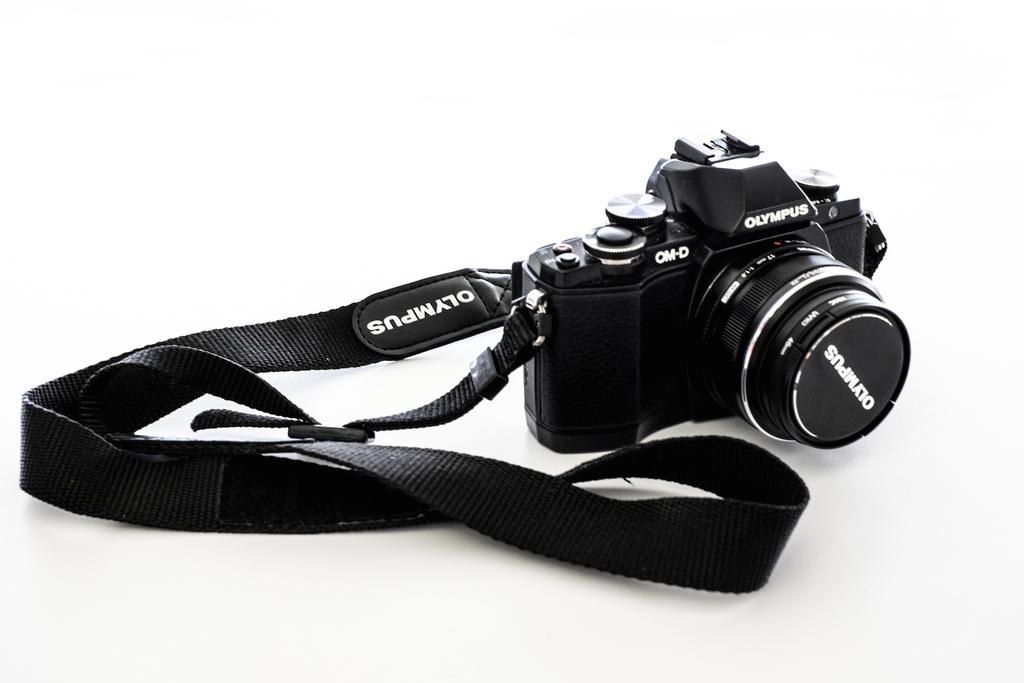What object is the main subject of the picture? The main subject of the picture is a camera. What is the color of the camera? The camera is black in color. Are there any markings or text on the camera? Yes, there are words written on the camera. Is there anything attached to the camera? Yes, there is a tag attached to the camera. What is the surface beneath the camera? The camera is on a white surface. How many laborers are working on the roof in the image? There are no laborers or roof present in the image; it features a camera on a white surface. What type of flock is visible in the image? There is no flock present in the image; it features a camera on a white surface. 